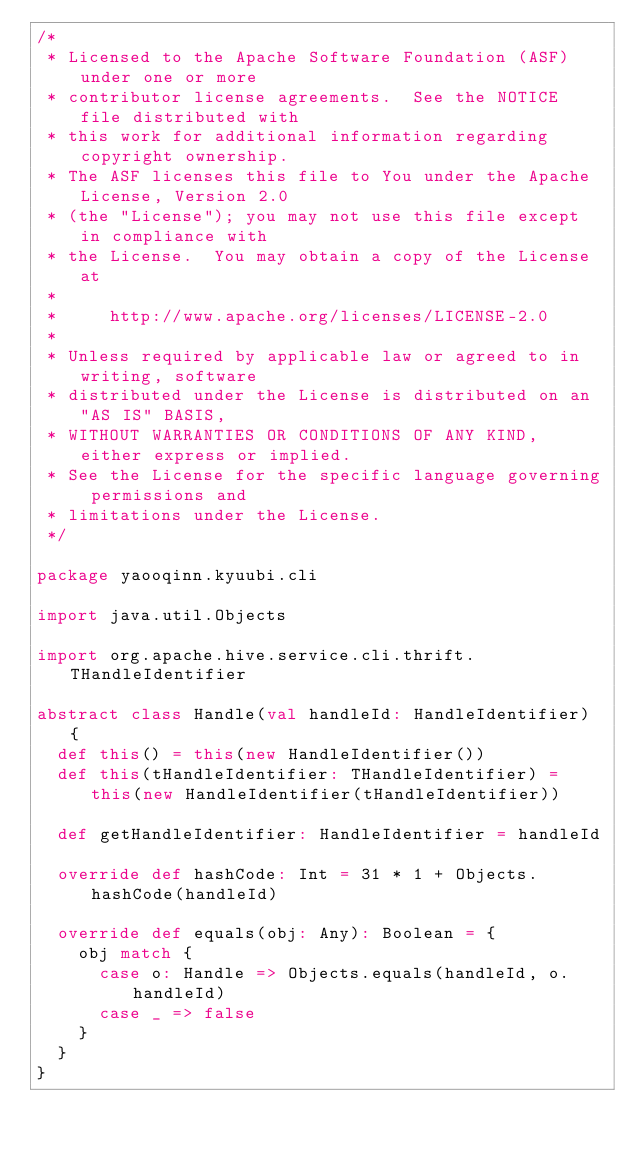Convert code to text. <code><loc_0><loc_0><loc_500><loc_500><_Scala_>/*
 * Licensed to the Apache Software Foundation (ASF) under one or more
 * contributor license agreements.  See the NOTICE file distributed with
 * this work for additional information regarding copyright ownership.
 * The ASF licenses this file to You under the Apache License, Version 2.0
 * (the "License"); you may not use this file except in compliance with
 * the License.  You may obtain a copy of the License at
 *
 *     http://www.apache.org/licenses/LICENSE-2.0
 *
 * Unless required by applicable law or agreed to in writing, software
 * distributed under the License is distributed on an "AS IS" BASIS,
 * WITHOUT WARRANTIES OR CONDITIONS OF ANY KIND, either express or implied.
 * See the License for the specific language governing permissions and
 * limitations under the License.
 */

package yaooqinn.kyuubi.cli

import java.util.Objects

import org.apache.hive.service.cli.thrift.THandleIdentifier

abstract class Handle(val handleId: HandleIdentifier) {
  def this() = this(new HandleIdentifier())
  def this(tHandleIdentifier: THandleIdentifier) = this(new HandleIdentifier(tHandleIdentifier))

  def getHandleIdentifier: HandleIdentifier = handleId

  override def hashCode: Int = 31 * 1 + Objects.hashCode(handleId)

  override def equals(obj: Any): Boolean = {
    obj match {
      case o: Handle => Objects.equals(handleId, o.handleId)
      case _ => false
    }
  }
}
</code> 